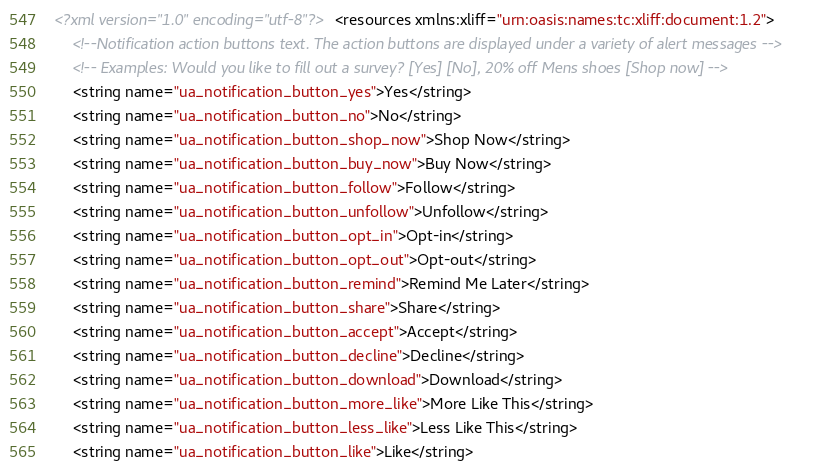<code> <loc_0><loc_0><loc_500><loc_500><_XML_><?xml version="1.0" encoding="utf-8"?><resources xmlns:xliff="urn:oasis:names:tc:xliff:document:1.2">
    <!--Notification action buttons text. The action buttons are displayed under a variety of alert messages -->
    <!-- Examples: Would you like to fill out a survey? [Yes] [No], 20% off Mens shoes [Shop now] -->
    <string name="ua_notification_button_yes">Yes</string>
    <string name="ua_notification_button_no">No</string>
    <string name="ua_notification_button_shop_now">Shop Now</string>
    <string name="ua_notification_button_buy_now">Buy Now</string>
    <string name="ua_notification_button_follow">Follow</string>
    <string name="ua_notification_button_unfollow">Unfollow</string>
    <string name="ua_notification_button_opt_in">Opt-in</string>
    <string name="ua_notification_button_opt_out">Opt-out</string>
    <string name="ua_notification_button_remind">Remind Me Later</string>
    <string name="ua_notification_button_share">Share</string>
    <string name="ua_notification_button_accept">Accept</string>
    <string name="ua_notification_button_decline">Decline</string>
    <string name="ua_notification_button_download">Download</string>
    <string name="ua_notification_button_more_like">More Like This</string>
    <string name="ua_notification_button_less_like">Less Like This</string>
    <string name="ua_notification_button_like">Like</string></code> 